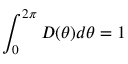<formula> <loc_0><loc_0><loc_500><loc_500>\int _ { 0 } ^ { 2 \pi } D ( \theta ) d \theta = 1</formula> 